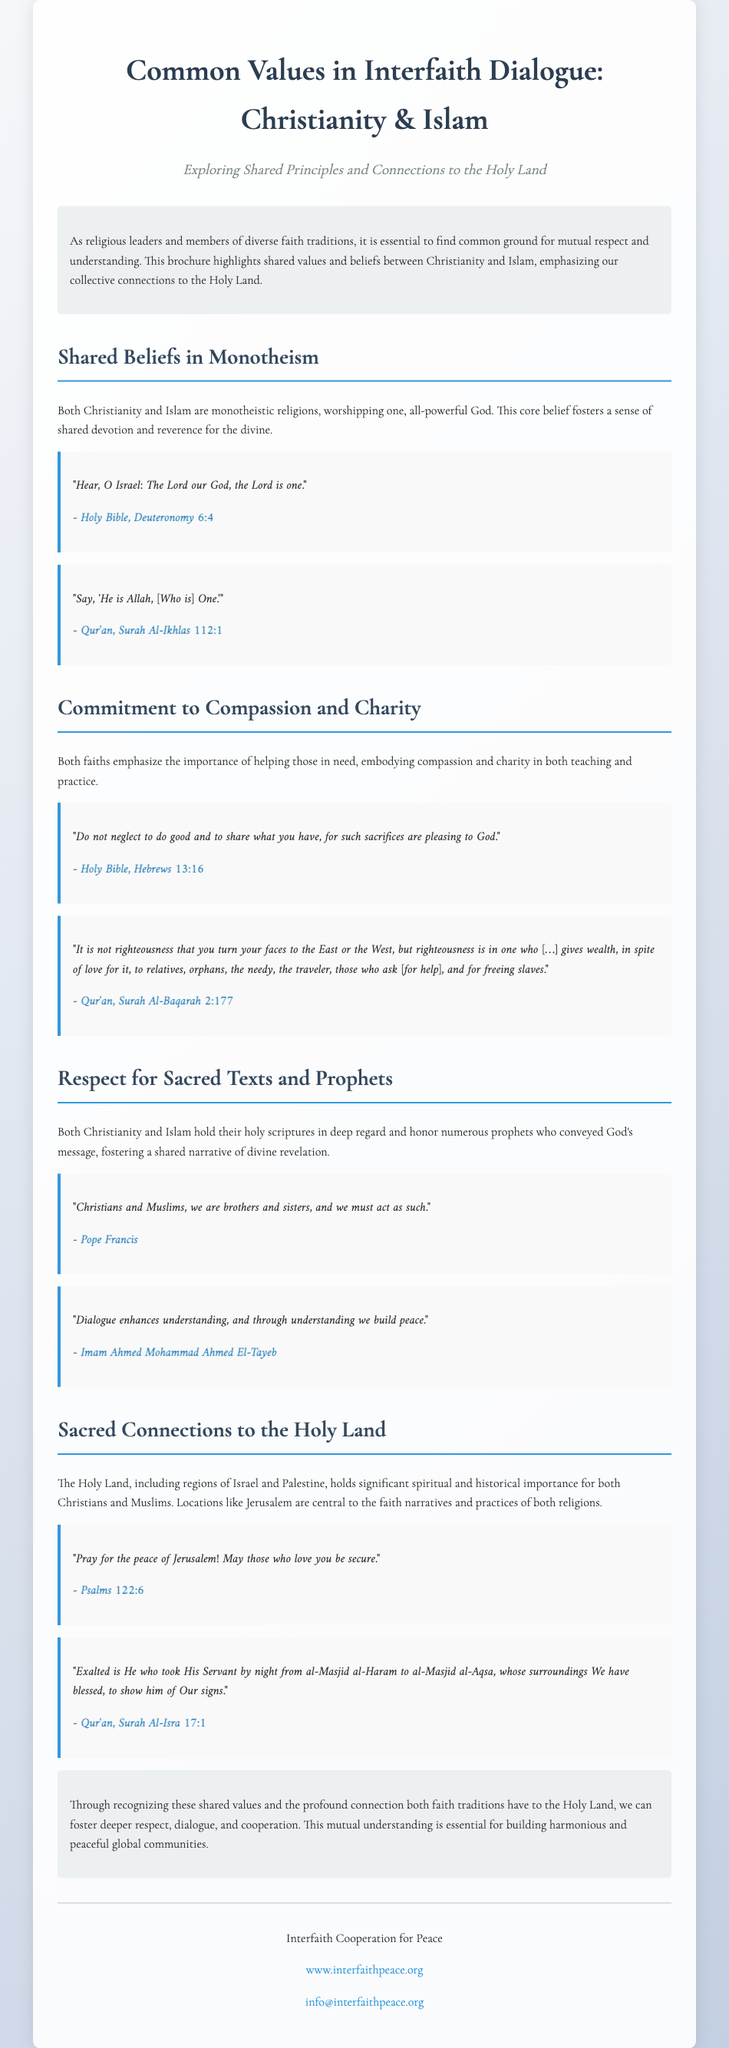What are the two faiths discussed in the brochure? The brochure focuses on shared values between Christianity and Islam.
Answer: Christianity and Islam What is the title of the brochure? The title summarizes the topics covered, specifically regarding shared values and interfaith dialogue.
Answer: Common Values in Interfaith Dialogue: Christianity & Islam Who is quoted as saying, "Christians and Muslims, we are brothers and sisters, and we must act as such"? This quote from a prominent religious leader emphasizes the connection between the two faiths.
Answer: Pope Francis What section addresses the importance of compassion and charity? This highlights one of the core values shared by both faiths in the context of helping the needy.
Answer: Commitment to Compassion and Charity How many sections are there in the brochure? The document features distinct sections focusing on various shared beliefs and connections.
Answer: Four What is one of the sources quoted from the Qur'an regarding respect for sacred texts? This quote strengthens the understanding of divine messaging in a shared religious context.
Answer: Qur'an, Surah Al-Isra 17:1 What is the overall aim of the brochure? The brochure seeks to foster mutual understanding and respect between different faiths.
Answer: Foster deeper respect, dialogue, and cooperation Which city is specifically mentioned in the context of sacred connections to the Holy Land? The city holds profound significance for both Christians and Muslims, forming a focal point in the discussion.
Answer: Jerusalem 